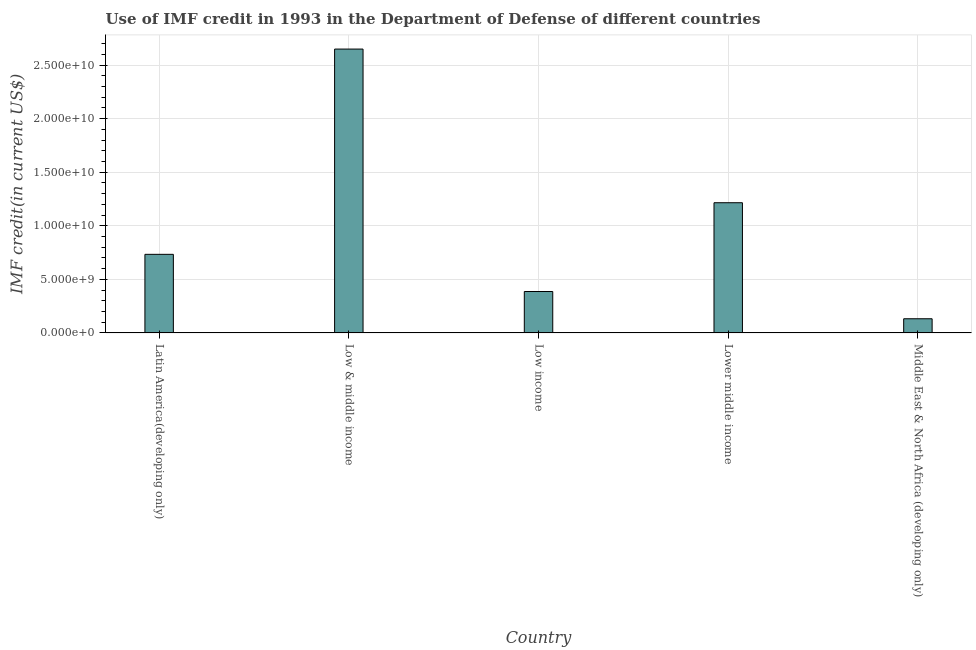Does the graph contain grids?
Your answer should be very brief. Yes. What is the title of the graph?
Your answer should be very brief. Use of IMF credit in 1993 in the Department of Defense of different countries. What is the label or title of the X-axis?
Your response must be concise. Country. What is the label or title of the Y-axis?
Offer a very short reply. IMF credit(in current US$). What is the use of imf credit in dod in Latin America(developing only)?
Make the answer very short. 7.34e+09. Across all countries, what is the maximum use of imf credit in dod?
Offer a very short reply. 2.65e+1. Across all countries, what is the minimum use of imf credit in dod?
Your answer should be compact. 1.32e+09. In which country was the use of imf credit in dod minimum?
Keep it short and to the point. Middle East & North Africa (developing only). What is the sum of the use of imf credit in dod?
Your answer should be very brief. 5.12e+1. What is the difference between the use of imf credit in dod in Latin America(developing only) and Middle East & North Africa (developing only)?
Your answer should be very brief. 6.01e+09. What is the average use of imf credit in dod per country?
Provide a short and direct response. 1.02e+1. What is the median use of imf credit in dod?
Provide a short and direct response. 7.34e+09. In how many countries, is the use of imf credit in dod greater than 9000000000 US$?
Provide a short and direct response. 2. What is the ratio of the use of imf credit in dod in Low & middle income to that in Low income?
Give a very brief answer. 6.85. Is the difference between the use of imf credit in dod in Low income and Middle East & North Africa (developing only) greater than the difference between any two countries?
Ensure brevity in your answer.  No. What is the difference between the highest and the second highest use of imf credit in dod?
Ensure brevity in your answer.  1.43e+1. Is the sum of the use of imf credit in dod in Latin America(developing only) and Low income greater than the maximum use of imf credit in dod across all countries?
Offer a very short reply. No. What is the difference between the highest and the lowest use of imf credit in dod?
Keep it short and to the point. 2.52e+1. In how many countries, is the use of imf credit in dod greater than the average use of imf credit in dod taken over all countries?
Offer a terse response. 2. How many bars are there?
Provide a succinct answer. 5. Are all the bars in the graph horizontal?
Make the answer very short. No. What is the IMF credit(in current US$) of Latin America(developing only)?
Give a very brief answer. 7.34e+09. What is the IMF credit(in current US$) of Low & middle income?
Make the answer very short. 2.65e+1. What is the IMF credit(in current US$) in Low income?
Your answer should be very brief. 3.87e+09. What is the IMF credit(in current US$) in Lower middle income?
Your answer should be very brief. 1.22e+1. What is the IMF credit(in current US$) of Middle East & North Africa (developing only)?
Offer a very short reply. 1.32e+09. What is the difference between the IMF credit(in current US$) in Latin America(developing only) and Low & middle income?
Ensure brevity in your answer.  -1.92e+1. What is the difference between the IMF credit(in current US$) in Latin America(developing only) and Low income?
Your answer should be compact. 3.47e+09. What is the difference between the IMF credit(in current US$) in Latin America(developing only) and Lower middle income?
Your response must be concise. -4.82e+09. What is the difference between the IMF credit(in current US$) in Latin America(developing only) and Middle East & North Africa (developing only)?
Give a very brief answer. 6.01e+09. What is the difference between the IMF credit(in current US$) in Low & middle income and Low income?
Provide a short and direct response. 2.26e+1. What is the difference between the IMF credit(in current US$) in Low & middle income and Lower middle income?
Your answer should be compact. 1.43e+1. What is the difference between the IMF credit(in current US$) in Low & middle income and Middle East & North Africa (developing only)?
Your answer should be compact. 2.52e+1. What is the difference between the IMF credit(in current US$) in Low income and Lower middle income?
Keep it short and to the point. -8.29e+09. What is the difference between the IMF credit(in current US$) in Low income and Middle East & North Africa (developing only)?
Offer a very short reply. 2.54e+09. What is the difference between the IMF credit(in current US$) in Lower middle income and Middle East & North Africa (developing only)?
Provide a succinct answer. 1.08e+1. What is the ratio of the IMF credit(in current US$) in Latin America(developing only) to that in Low & middle income?
Offer a terse response. 0.28. What is the ratio of the IMF credit(in current US$) in Latin America(developing only) to that in Low income?
Ensure brevity in your answer.  1.9. What is the ratio of the IMF credit(in current US$) in Latin America(developing only) to that in Lower middle income?
Ensure brevity in your answer.  0.6. What is the ratio of the IMF credit(in current US$) in Latin America(developing only) to that in Middle East & North Africa (developing only)?
Your response must be concise. 5.54. What is the ratio of the IMF credit(in current US$) in Low & middle income to that in Low income?
Make the answer very short. 6.85. What is the ratio of the IMF credit(in current US$) in Low & middle income to that in Lower middle income?
Keep it short and to the point. 2.18. What is the ratio of the IMF credit(in current US$) in Low & middle income to that in Middle East & North Africa (developing only)?
Offer a terse response. 20.02. What is the ratio of the IMF credit(in current US$) in Low income to that in Lower middle income?
Provide a succinct answer. 0.32. What is the ratio of the IMF credit(in current US$) in Low income to that in Middle East & North Africa (developing only)?
Give a very brief answer. 2.92. What is the ratio of the IMF credit(in current US$) in Lower middle income to that in Middle East & North Africa (developing only)?
Ensure brevity in your answer.  9.18. 